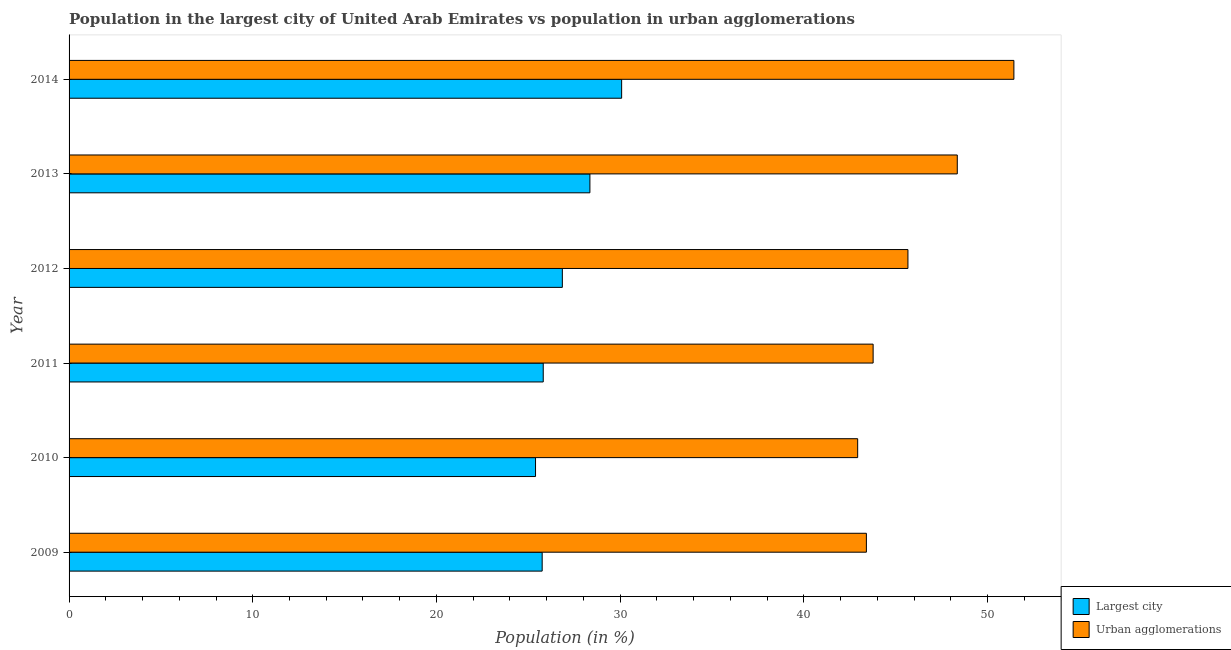How many different coloured bars are there?
Your answer should be compact. 2. Are the number of bars per tick equal to the number of legend labels?
Your answer should be very brief. Yes. Are the number of bars on each tick of the Y-axis equal?
Your answer should be very brief. Yes. How many bars are there on the 6th tick from the bottom?
Keep it short and to the point. 2. What is the label of the 2nd group of bars from the top?
Make the answer very short. 2013. What is the population in the largest city in 2009?
Your answer should be very brief. 25.75. Across all years, what is the maximum population in the largest city?
Give a very brief answer. 30.08. Across all years, what is the minimum population in the largest city?
Make the answer very short. 25.39. What is the total population in urban agglomerations in the graph?
Your answer should be compact. 275.56. What is the difference between the population in the largest city in 2009 and that in 2012?
Offer a terse response. -1.1. What is the difference between the population in urban agglomerations in 2013 and the population in the largest city in 2011?
Provide a succinct answer. 22.54. What is the average population in the largest city per year?
Offer a very short reply. 27.04. In the year 2009, what is the difference between the population in urban agglomerations and population in the largest city?
Keep it short and to the point. 17.65. In how many years, is the population in the largest city greater than 2 %?
Make the answer very short. 6. What is the ratio of the population in urban agglomerations in 2009 to that in 2014?
Ensure brevity in your answer.  0.84. Is the population in urban agglomerations in 2010 less than that in 2013?
Keep it short and to the point. Yes. What is the difference between the highest and the second highest population in the largest city?
Your answer should be compact. 1.73. What is the difference between the highest and the lowest population in the largest city?
Give a very brief answer. 4.69. What does the 2nd bar from the top in 2011 represents?
Your answer should be compact. Largest city. What does the 2nd bar from the bottom in 2012 represents?
Give a very brief answer. Urban agglomerations. How many bars are there?
Your answer should be very brief. 12. Are all the bars in the graph horizontal?
Your answer should be very brief. Yes. What is the difference between two consecutive major ticks on the X-axis?
Give a very brief answer. 10. Are the values on the major ticks of X-axis written in scientific E-notation?
Make the answer very short. No. Does the graph contain grids?
Offer a terse response. No. How many legend labels are there?
Offer a terse response. 2. How are the legend labels stacked?
Your answer should be very brief. Vertical. What is the title of the graph?
Keep it short and to the point. Population in the largest city of United Arab Emirates vs population in urban agglomerations. What is the label or title of the X-axis?
Your answer should be very brief. Population (in %). What is the Population (in %) of Largest city in 2009?
Your answer should be very brief. 25.75. What is the Population (in %) of Urban agglomerations in 2009?
Keep it short and to the point. 43.4. What is the Population (in %) of Largest city in 2010?
Provide a short and direct response. 25.39. What is the Population (in %) in Urban agglomerations in 2010?
Provide a succinct answer. 42.93. What is the Population (in %) of Largest city in 2011?
Your answer should be compact. 25.81. What is the Population (in %) in Urban agglomerations in 2011?
Your answer should be compact. 43.77. What is the Population (in %) of Largest city in 2012?
Keep it short and to the point. 26.85. What is the Population (in %) of Urban agglomerations in 2012?
Your answer should be compact. 45.67. What is the Population (in %) of Largest city in 2013?
Keep it short and to the point. 28.35. What is the Population (in %) of Urban agglomerations in 2013?
Give a very brief answer. 48.35. What is the Population (in %) in Largest city in 2014?
Give a very brief answer. 30.08. What is the Population (in %) of Urban agglomerations in 2014?
Make the answer very short. 51.43. Across all years, what is the maximum Population (in %) of Largest city?
Make the answer very short. 30.08. Across all years, what is the maximum Population (in %) of Urban agglomerations?
Ensure brevity in your answer.  51.43. Across all years, what is the minimum Population (in %) of Largest city?
Ensure brevity in your answer.  25.39. Across all years, what is the minimum Population (in %) in Urban agglomerations?
Keep it short and to the point. 42.93. What is the total Population (in %) of Largest city in the graph?
Give a very brief answer. 162.25. What is the total Population (in %) of Urban agglomerations in the graph?
Offer a terse response. 275.56. What is the difference between the Population (in %) in Largest city in 2009 and that in 2010?
Make the answer very short. 0.36. What is the difference between the Population (in %) in Urban agglomerations in 2009 and that in 2010?
Your response must be concise. 0.47. What is the difference between the Population (in %) in Largest city in 2009 and that in 2011?
Provide a short and direct response. -0.06. What is the difference between the Population (in %) in Urban agglomerations in 2009 and that in 2011?
Ensure brevity in your answer.  -0.37. What is the difference between the Population (in %) in Largest city in 2009 and that in 2012?
Give a very brief answer. -1.1. What is the difference between the Population (in %) in Urban agglomerations in 2009 and that in 2012?
Your answer should be compact. -2.26. What is the difference between the Population (in %) of Largest city in 2009 and that in 2013?
Ensure brevity in your answer.  -2.6. What is the difference between the Population (in %) of Urban agglomerations in 2009 and that in 2013?
Ensure brevity in your answer.  -4.95. What is the difference between the Population (in %) of Largest city in 2009 and that in 2014?
Your answer should be very brief. -4.33. What is the difference between the Population (in %) of Urban agglomerations in 2009 and that in 2014?
Keep it short and to the point. -8.03. What is the difference between the Population (in %) of Largest city in 2010 and that in 2011?
Your answer should be compact. -0.42. What is the difference between the Population (in %) of Urban agglomerations in 2010 and that in 2011?
Ensure brevity in your answer.  -0.84. What is the difference between the Population (in %) in Largest city in 2010 and that in 2012?
Ensure brevity in your answer.  -1.46. What is the difference between the Population (in %) in Urban agglomerations in 2010 and that in 2012?
Offer a very short reply. -2.74. What is the difference between the Population (in %) in Largest city in 2010 and that in 2013?
Ensure brevity in your answer.  -2.96. What is the difference between the Population (in %) of Urban agglomerations in 2010 and that in 2013?
Make the answer very short. -5.42. What is the difference between the Population (in %) in Largest city in 2010 and that in 2014?
Make the answer very short. -4.69. What is the difference between the Population (in %) in Urban agglomerations in 2010 and that in 2014?
Provide a short and direct response. -8.5. What is the difference between the Population (in %) in Largest city in 2011 and that in 2012?
Your response must be concise. -1.04. What is the difference between the Population (in %) of Urban agglomerations in 2011 and that in 2012?
Keep it short and to the point. -1.9. What is the difference between the Population (in %) in Largest city in 2011 and that in 2013?
Keep it short and to the point. -2.54. What is the difference between the Population (in %) of Urban agglomerations in 2011 and that in 2013?
Your answer should be compact. -4.58. What is the difference between the Population (in %) of Largest city in 2011 and that in 2014?
Your answer should be compact. -4.27. What is the difference between the Population (in %) in Urban agglomerations in 2011 and that in 2014?
Give a very brief answer. -7.66. What is the difference between the Population (in %) in Largest city in 2012 and that in 2013?
Provide a short and direct response. -1.5. What is the difference between the Population (in %) of Urban agglomerations in 2012 and that in 2013?
Your response must be concise. -2.69. What is the difference between the Population (in %) in Largest city in 2012 and that in 2014?
Provide a short and direct response. -3.23. What is the difference between the Population (in %) in Urban agglomerations in 2012 and that in 2014?
Give a very brief answer. -5.77. What is the difference between the Population (in %) of Largest city in 2013 and that in 2014?
Keep it short and to the point. -1.73. What is the difference between the Population (in %) in Urban agglomerations in 2013 and that in 2014?
Provide a succinct answer. -3.08. What is the difference between the Population (in %) in Largest city in 2009 and the Population (in %) in Urban agglomerations in 2010?
Your answer should be compact. -17.18. What is the difference between the Population (in %) of Largest city in 2009 and the Population (in %) of Urban agglomerations in 2011?
Your answer should be very brief. -18.02. What is the difference between the Population (in %) in Largest city in 2009 and the Population (in %) in Urban agglomerations in 2012?
Your answer should be very brief. -19.91. What is the difference between the Population (in %) of Largest city in 2009 and the Population (in %) of Urban agglomerations in 2013?
Make the answer very short. -22.6. What is the difference between the Population (in %) in Largest city in 2009 and the Population (in %) in Urban agglomerations in 2014?
Your answer should be very brief. -25.68. What is the difference between the Population (in %) in Largest city in 2010 and the Population (in %) in Urban agglomerations in 2011?
Provide a short and direct response. -18.38. What is the difference between the Population (in %) in Largest city in 2010 and the Population (in %) in Urban agglomerations in 2012?
Keep it short and to the point. -20.27. What is the difference between the Population (in %) in Largest city in 2010 and the Population (in %) in Urban agglomerations in 2013?
Your answer should be very brief. -22.96. What is the difference between the Population (in %) in Largest city in 2010 and the Population (in %) in Urban agglomerations in 2014?
Your answer should be very brief. -26.04. What is the difference between the Population (in %) in Largest city in 2011 and the Population (in %) in Urban agglomerations in 2012?
Make the answer very short. -19.85. What is the difference between the Population (in %) in Largest city in 2011 and the Population (in %) in Urban agglomerations in 2013?
Offer a very short reply. -22.54. What is the difference between the Population (in %) in Largest city in 2011 and the Population (in %) in Urban agglomerations in 2014?
Your response must be concise. -25.62. What is the difference between the Population (in %) in Largest city in 2012 and the Population (in %) in Urban agglomerations in 2013?
Provide a short and direct response. -21.5. What is the difference between the Population (in %) of Largest city in 2012 and the Population (in %) of Urban agglomerations in 2014?
Your response must be concise. -24.58. What is the difference between the Population (in %) of Largest city in 2013 and the Population (in %) of Urban agglomerations in 2014?
Ensure brevity in your answer.  -23.08. What is the average Population (in %) in Largest city per year?
Provide a short and direct response. 27.04. What is the average Population (in %) of Urban agglomerations per year?
Offer a terse response. 45.93. In the year 2009, what is the difference between the Population (in %) of Largest city and Population (in %) of Urban agglomerations?
Keep it short and to the point. -17.65. In the year 2010, what is the difference between the Population (in %) in Largest city and Population (in %) in Urban agglomerations?
Offer a terse response. -17.54. In the year 2011, what is the difference between the Population (in %) of Largest city and Population (in %) of Urban agglomerations?
Offer a very short reply. -17.96. In the year 2012, what is the difference between the Population (in %) in Largest city and Population (in %) in Urban agglomerations?
Offer a very short reply. -18.81. In the year 2013, what is the difference between the Population (in %) in Largest city and Population (in %) in Urban agglomerations?
Provide a succinct answer. -20. In the year 2014, what is the difference between the Population (in %) of Largest city and Population (in %) of Urban agglomerations?
Make the answer very short. -21.35. What is the ratio of the Population (in %) of Largest city in 2009 to that in 2010?
Your answer should be compact. 1.01. What is the ratio of the Population (in %) in Urban agglomerations in 2009 to that in 2011?
Provide a succinct answer. 0.99. What is the ratio of the Population (in %) in Largest city in 2009 to that in 2012?
Your answer should be very brief. 0.96. What is the ratio of the Population (in %) of Urban agglomerations in 2009 to that in 2012?
Offer a very short reply. 0.95. What is the ratio of the Population (in %) of Largest city in 2009 to that in 2013?
Offer a very short reply. 0.91. What is the ratio of the Population (in %) of Urban agglomerations in 2009 to that in 2013?
Keep it short and to the point. 0.9. What is the ratio of the Population (in %) in Largest city in 2009 to that in 2014?
Provide a succinct answer. 0.86. What is the ratio of the Population (in %) in Urban agglomerations in 2009 to that in 2014?
Offer a very short reply. 0.84. What is the ratio of the Population (in %) in Largest city in 2010 to that in 2011?
Your response must be concise. 0.98. What is the ratio of the Population (in %) in Urban agglomerations in 2010 to that in 2011?
Your answer should be very brief. 0.98. What is the ratio of the Population (in %) of Largest city in 2010 to that in 2012?
Make the answer very short. 0.95. What is the ratio of the Population (in %) of Urban agglomerations in 2010 to that in 2012?
Your answer should be very brief. 0.94. What is the ratio of the Population (in %) in Largest city in 2010 to that in 2013?
Keep it short and to the point. 0.9. What is the ratio of the Population (in %) in Urban agglomerations in 2010 to that in 2013?
Your response must be concise. 0.89. What is the ratio of the Population (in %) of Largest city in 2010 to that in 2014?
Your response must be concise. 0.84. What is the ratio of the Population (in %) in Urban agglomerations in 2010 to that in 2014?
Your answer should be very brief. 0.83. What is the ratio of the Population (in %) of Largest city in 2011 to that in 2012?
Make the answer very short. 0.96. What is the ratio of the Population (in %) in Urban agglomerations in 2011 to that in 2012?
Provide a short and direct response. 0.96. What is the ratio of the Population (in %) in Largest city in 2011 to that in 2013?
Your response must be concise. 0.91. What is the ratio of the Population (in %) of Urban agglomerations in 2011 to that in 2013?
Give a very brief answer. 0.91. What is the ratio of the Population (in %) of Largest city in 2011 to that in 2014?
Give a very brief answer. 0.86. What is the ratio of the Population (in %) in Urban agglomerations in 2011 to that in 2014?
Your answer should be very brief. 0.85. What is the ratio of the Population (in %) in Largest city in 2012 to that in 2013?
Your response must be concise. 0.95. What is the ratio of the Population (in %) of Urban agglomerations in 2012 to that in 2013?
Your response must be concise. 0.94. What is the ratio of the Population (in %) in Largest city in 2012 to that in 2014?
Your answer should be very brief. 0.89. What is the ratio of the Population (in %) of Urban agglomerations in 2012 to that in 2014?
Give a very brief answer. 0.89. What is the ratio of the Population (in %) of Largest city in 2013 to that in 2014?
Offer a very short reply. 0.94. What is the ratio of the Population (in %) of Urban agglomerations in 2013 to that in 2014?
Offer a terse response. 0.94. What is the difference between the highest and the second highest Population (in %) in Largest city?
Make the answer very short. 1.73. What is the difference between the highest and the second highest Population (in %) of Urban agglomerations?
Your answer should be very brief. 3.08. What is the difference between the highest and the lowest Population (in %) in Largest city?
Your response must be concise. 4.69. What is the difference between the highest and the lowest Population (in %) in Urban agglomerations?
Ensure brevity in your answer.  8.5. 